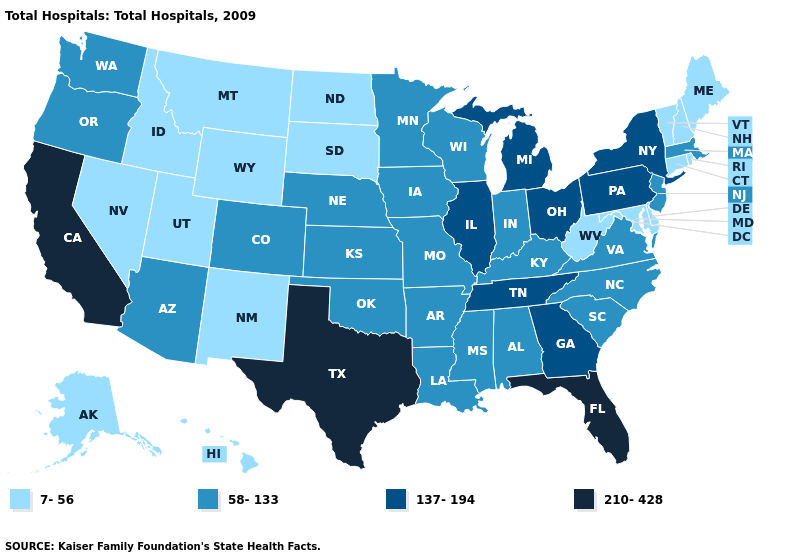What is the highest value in the South ?
Concise answer only. 210-428. Among the states that border Oklahoma , which have the highest value?
Give a very brief answer. Texas. What is the value of Rhode Island?
Write a very short answer. 7-56. Does Louisiana have the same value as South Carolina?
Quick response, please. Yes. Among the states that border Virginia , which have the highest value?
Be succinct. Tennessee. Name the states that have a value in the range 210-428?
Be succinct. California, Florida, Texas. What is the value of Arizona?
Keep it brief. 58-133. Does Illinois have a higher value than Massachusetts?
Concise answer only. Yes. Name the states that have a value in the range 58-133?
Give a very brief answer. Alabama, Arizona, Arkansas, Colorado, Indiana, Iowa, Kansas, Kentucky, Louisiana, Massachusetts, Minnesota, Mississippi, Missouri, Nebraska, New Jersey, North Carolina, Oklahoma, Oregon, South Carolina, Virginia, Washington, Wisconsin. What is the value of Hawaii?
Concise answer only. 7-56. Among the states that border Texas , which have the lowest value?
Quick response, please. New Mexico. Does Massachusetts have the same value as Mississippi?
Quick response, please. Yes. What is the highest value in states that border Utah?
Write a very short answer. 58-133. Name the states that have a value in the range 58-133?
Keep it brief. Alabama, Arizona, Arkansas, Colorado, Indiana, Iowa, Kansas, Kentucky, Louisiana, Massachusetts, Minnesota, Mississippi, Missouri, Nebraska, New Jersey, North Carolina, Oklahoma, Oregon, South Carolina, Virginia, Washington, Wisconsin. Among the states that border Montana , which have the lowest value?
Keep it brief. Idaho, North Dakota, South Dakota, Wyoming. 